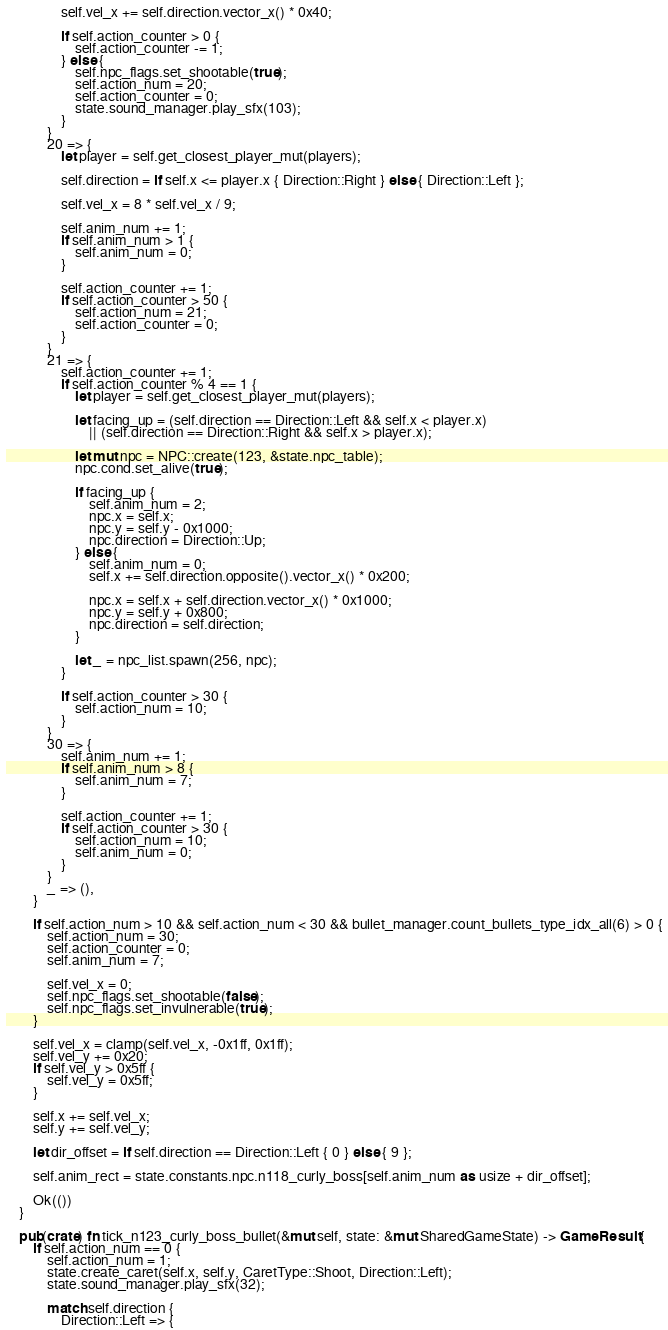<code> <loc_0><loc_0><loc_500><loc_500><_Rust_>                self.vel_x += self.direction.vector_x() * 0x40;

                if self.action_counter > 0 {
                    self.action_counter -= 1;
                } else {
                    self.npc_flags.set_shootable(true);
                    self.action_num = 20;
                    self.action_counter = 0;
                    state.sound_manager.play_sfx(103);
                }
            }
            20 => {
                let player = self.get_closest_player_mut(players);

                self.direction = if self.x <= player.x { Direction::Right } else { Direction::Left };

                self.vel_x = 8 * self.vel_x / 9;

                self.anim_num += 1;
                if self.anim_num > 1 {
                    self.anim_num = 0;
                }

                self.action_counter += 1;
                if self.action_counter > 50 {
                    self.action_num = 21;
                    self.action_counter = 0;
                }
            }
            21 => {
                self.action_counter += 1;
                if self.action_counter % 4 == 1 {
                    let player = self.get_closest_player_mut(players);

                    let facing_up = (self.direction == Direction::Left && self.x < player.x)
                        || (self.direction == Direction::Right && self.x > player.x);

                    let mut npc = NPC::create(123, &state.npc_table);
                    npc.cond.set_alive(true);

                    if facing_up {
                        self.anim_num = 2;
                        npc.x = self.x;
                        npc.y = self.y - 0x1000;
                        npc.direction = Direction::Up;
                    } else {
                        self.anim_num = 0;
                        self.x += self.direction.opposite().vector_x() * 0x200;

                        npc.x = self.x + self.direction.vector_x() * 0x1000;
                        npc.y = self.y + 0x800;
                        npc.direction = self.direction;
                    }

                    let _ = npc_list.spawn(256, npc);
                }

                if self.action_counter > 30 {
                    self.action_num = 10;
                }
            }
            30 => {
                self.anim_num += 1;
                if self.anim_num > 8 {
                    self.anim_num = 7;
                }

                self.action_counter += 1;
                if self.action_counter > 30 {
                    self.action_num = 10;
                    self.anim_num = 0;
                }
            }
            _ => (),
        }

        if self.action_num > 10 && self.action_num < 30 && bullet_manager.count_bullets_type_idx_all(6) > 0 {
            self.action_num = 30;
            self.action_counter = 0;
            self.anim_num = 7;

            self.vel_x = 0;
            self.npc_flags.set_shootable(false);
            self.npc_flags.set_invulnerable(true);
        }

        self.vel_x = clamp(self.vel_x, -0x1ff, 0x1ff);
        self.vel_y += 0x20;
        if self.vel_y > 0x5ff {
            self.vel_y = 0x5ff;
        }

        self.x += self.vel_x;
        self.y += self.vel_y;

        let dir_offset = if self.direction == Direction::Left { 0 } else { 9 };

        self.anim_rect = state.constants.npc.n118_curly_boss[self.anim_num as usize + dir_offset];

        Ok(())
    }

    pub(crate) fn tick_n123_curly_boss_bullet(&mut self, state: &mut SharedGameState) -> GameResult {
        if self.action_num == 0 {
            self.action_num = 1;
            state.create_caret(self.x, self.y, CaretType::Shoot, Direction::Left);
            state.sound_manager.play_sfx(32);

            match self.direction {
                Direction::Left => {</code> 